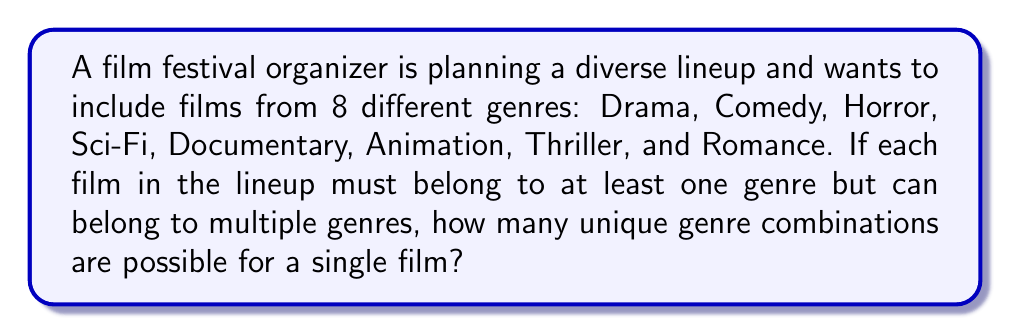Solve this math problem. To solve this problem, we need to use the concept of power sets. Each film can belong to any combination of genres, including a single genre or all genres.

1. First, we recognize that each genre has two possibilities for a film: it either belongs to that genre or it doesn't.

2. With 8 genres, we have 2 choices for each genre, and we're making this choice 8 times independently.

3. This scenario can be represented mathematically as $2^8$, where 2 represents the number of choices for each genre, and 8 is the number of genres.

4. We can calculate this as follows:

   $$2^8 = 2 \times 2 \times 2 \times 2 \times 2 \times 2 \times 2 \times 2 = 256$$

5. However, we need to subtract 1 from this total because a film must belong to at least one genre. The combination where a film belongs to no genres is not valid for this festival.

6. Therefore, the final number of unique genre combinations is:

   $$2^8 - 1 = 256 - 1 = 255$$

This means there are 255 possible unique genre combinations for a single film in the festival lineup.
Answer: 255 